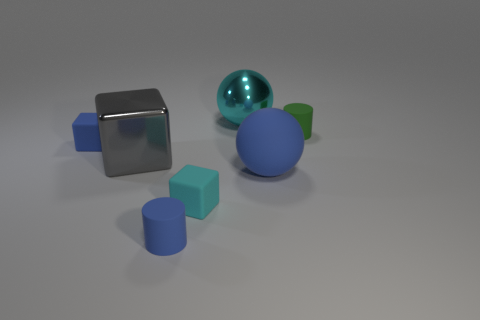Add 1 large brown spheres. How many objects exist? 8 Subtract all blue matte cubes. How many cubes are left? 2 Add 7 tiny yellow shiny cubes. How many tiny yellow shiny cubes exist? 7 Subtract 1 gray cubes. How many objects are left? 6 Subtract all cubes. How many objects are left? 4 Subtract all green matte objects. Subtract all gray metal cubes. How many objects are left? 5 Add 1 blue rubber cubes. How many blue rubber cubes are left? 2 